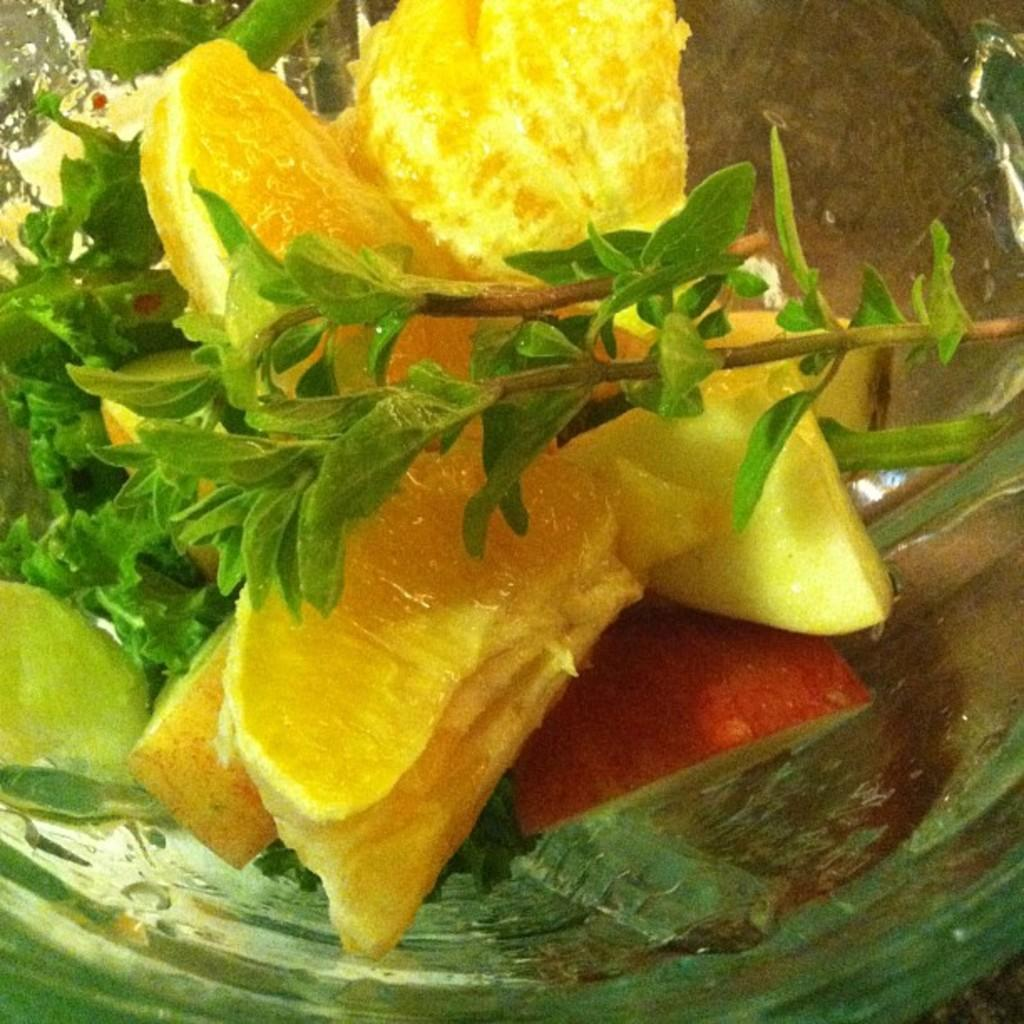What is on the glass plate in the image? There are pieces of orange and apple on the glass plate in the image. What else can be seen in the image besides the glass plate and fruits? There are stems with leaves in the image. Can you see a crow sitting on the patch of the skate in the image? There is no crow or skate present in the image; it only features a glass plate with fruits and stems with leaves. 